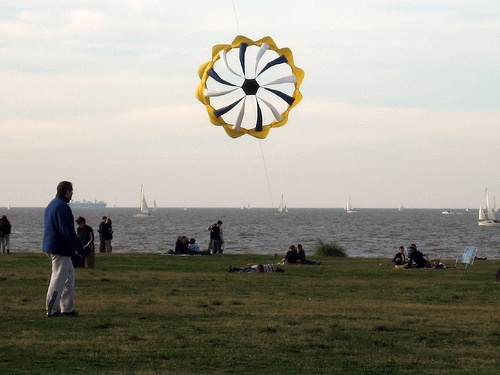Describe the objects in this image and their specific colors. I can see kite in lavender, lightgray, darkgray, black, and olive tones, people in lavender, black, gray, navy, and darkblue tones, people in lavender, black, and gray tones, people in lavender, black, and gray tones, and people in lavender, black, and gray tones in this image. 